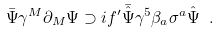<formula> <loc_0><loc_0><loc_500><loc_500>\bar { \Psi } \gamma ^ { M } \partial _ { M } \Psi \supset i f ^ { \prime } \bar { \hat { \Psi } } \gamma ^ { 5 } \beta _ { a } \sigma ^ { a } \hat { \Psi } \ .</formula> 